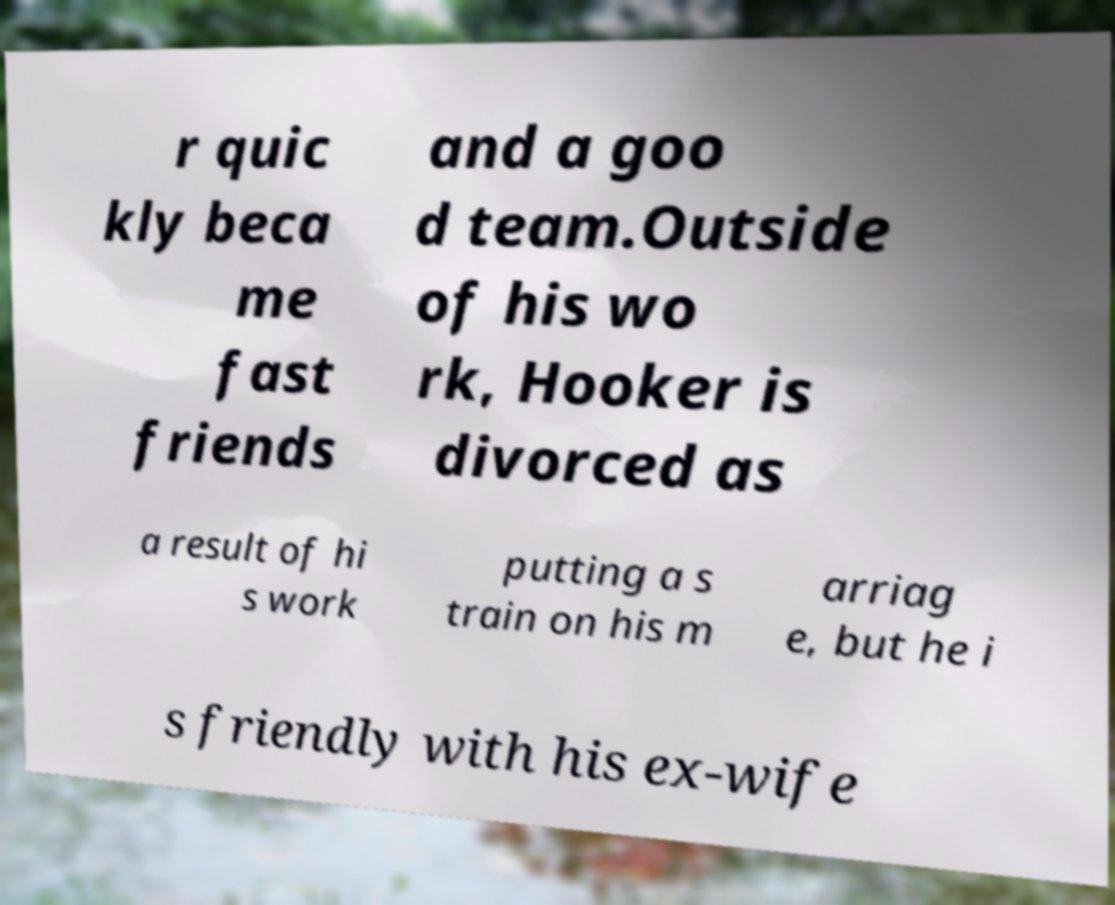For documentation purposes, I need the text within this image transcribed. Could you provide that? r quic kly beca me fast friends and a goo d team.Outside of his wo rk, Hooker is divorced as a result of hi s work putting a s train on his m arriag e, but he i s friendly with his ex-wife 